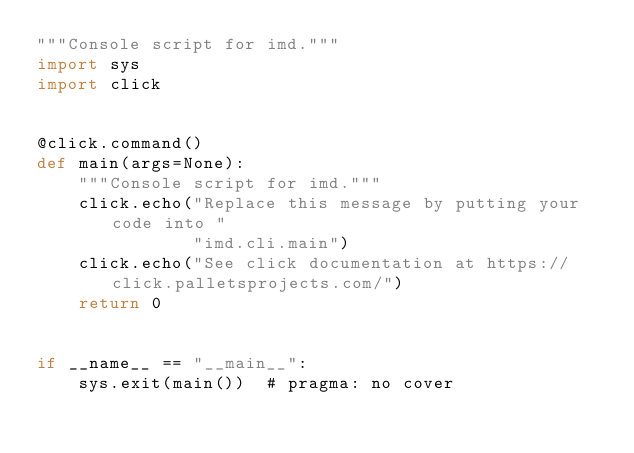<code> <loc_0><loc_0><loc_500><loc_500><_Python_>"""Console script for imd."""
import sys
import click


@click.command()
def main(args=None):
    """Console script for imd."""
    click.echo("Replace this message by putting your code into "
               "imd.cli.main")
    click.echo("See click documentation at https://click.palletsprojects.com/")
    return 0


if __name__ == "__main__":
    sys.exit(main())  # pragma: no cover
</code> 